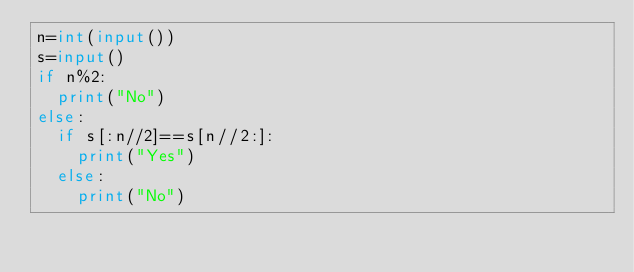Convert code to text. <code><loc_0><loc_0><loc_500><loc_500><_Python_>n=int(input())
s=input()
if n%2:
  print("No")
else:
  if s[:n//2]==s[n//2:]:
    print("Yes")
  else:
    print("No")
</code> 